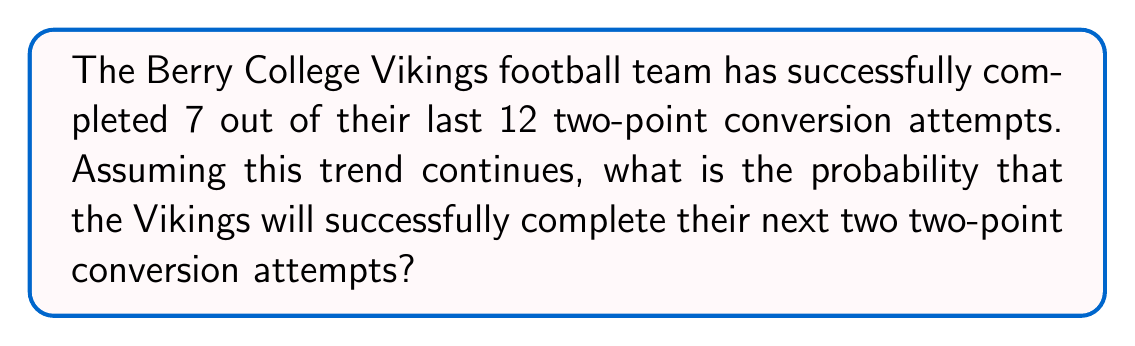Can you solve this math problem? Let's approach this step-by-step:

1) First, we need to determine the probability of a single successful two-point conversion attempt. This can be calculated by dividing the number of successful attempts by the total number of attempts:

   $P(\text{success}) = \frac{7}{12}$

2) Now, we need to find the probability of two consecutive successful attempts. Since these are independent events, we multiply the probabilities:

   $P(\text{two consecutive successes}) = P(\text{success}) \times P(\text{success})$

3) Substituting our value:

   $P(\text{two consecutive successes}) = \frac{7}{12} \times \frac{7}{12}$

4) Simplifying:

   $P(\text{two consecutive successes}) = \frac{49}{144}$

5) To express this as a decimal, we divide 49 by 144:

   $\frac{49}{144} \approx 0.3403$

6) To express as a percentage, we multiply by 100:

   $0.3403 \times 100 \approx 34.03\%$

Therefore, the probability of the Berry College Vikings successfully completing their next two two-point conversion attempts is approximately 34.03% or $\frac{49}{144}$.
Answer: $\frac{49}{144}$ or approximately 34.03% 